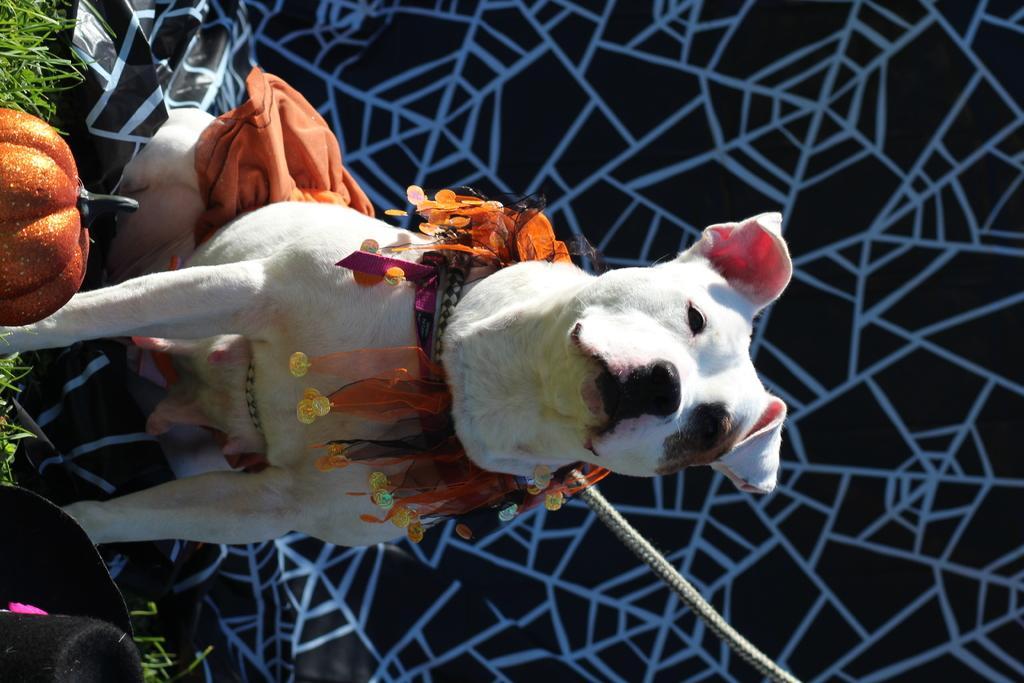In one or two sentences, can you explain what this image depicts? In this image in the front on the left side there is a hat which is black in colour and there is a fruit and there's grass on the ground. In the center there is a dog. In the background there is a curtain which is black and white in colour and there is a rope tied to the dog and there are objects on the dog which are visible. 